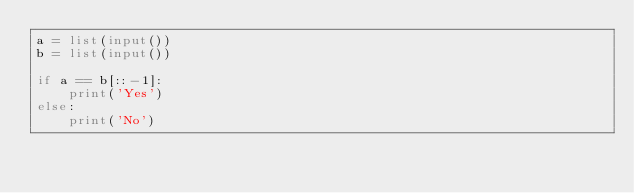<code> <loc_0><loc_0><loc_500><loc_500><_Python_>a = list(input())
b = list(input())

if a == b[::-1]:
	print('Yes')
else:
	print('No')</code> 